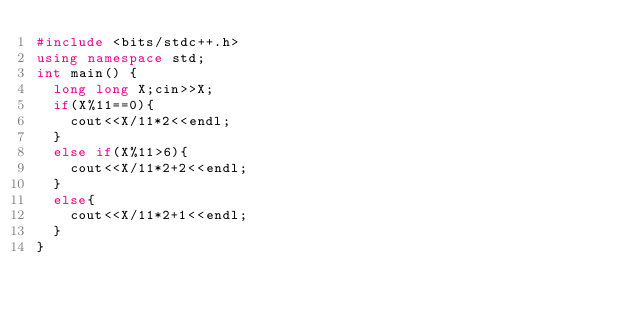<code> <loc_0><loc_0><loc_500><loc_500><_C++_>#include <bits/stdc++.h>
using namespace std;
int main() {
  long long X;cin>>X;
  if(X%11==0){
    cout<<X/11*2<<endl;
  }
  else if(X%11>6){
    cout<<X/11*2+2<<endl;
  }
  else{
    cout<<X/11*2+1<<endl;
  }
}
</code> 